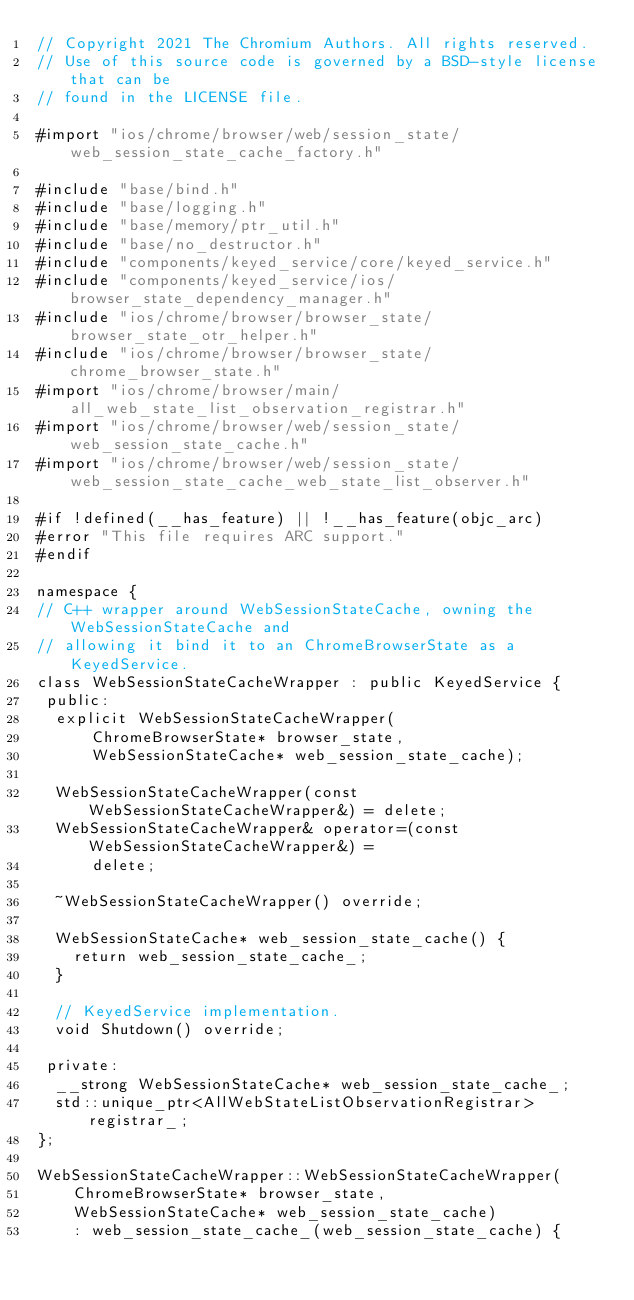<code> <loc_0><loc_0><loc_500><loc_500><_ObjectiveC_>// Copyright 2021 The Chromium Authors. All rights reserved.
// Use of this source code is governed by a BSD-style license that can be
// found in the LICENSE file.

#import "ios/chrome/browser/web/session_state/web_session_state_cache_factory.h"

#include "base/bind.h"
#include "base/logging.h"
#include "base/memory/ptr_util.h"
#include "base/no_destructor.h"
#include "components/keyed_service/core/keyed_service.h"
#include "components/keyed_service/ios/browser_state_dependency_manager.h"
#include "ios/chrome/browser/browser_state/browser_state_otr_helper.h"
#include "ios/chrome/browser/browser_state/chrome_browser_state.h"
#import "ios/chrome/browser/main/all_web_state_list_observation_registrar.h"
#import "ios/chrome/browser/web/session_state/web_session_state_cache.h"
#import "ios/chrome/browser/web/session_state/web_session_state_cache_web_state_list_observer.h"

#if !defined(__has_feature) || !__has_feature(objc_arc)
#error "This file requires ARC support."
#endif

namespace {
// C++ wrapper around WebSessionStateCache, owning the WebSessionStateCache and
// allowing it bind it to an ChromeBrowserState as a KeyedService.
class WebSessionStateCacheWrapper : public KeyedService {
 public:
  explicit WebSessionStateCacheWrapper(
      ChromeBrowserState* browser_state,
      WebSessionStateCache* web_session_state_cache);

  WebSessionStateCacheWrapper(const WebSessionStateCacheWrapper&) = delete;
  WebSessionStateCacheWrapper& operator=(const WebSessionStateCacheWrapper&) =
      delete;

  ~WebSessionStateCacheWrapper() override;

  WebSessionStateCache* web_session_state_cache() {
    return web_session_state_cache_;
  }

  // KeyedService implementation.
  void Shutdown() override;

 private:
  __strong WebSessionStateCache* web_session_state_cache_;
  std::unique_ptr<AllWebStateListObservationRegistrar> registrar_;
};

WebSessionStateCacheWrapper::WebSessionStateCacheWrapper(
    ChromeBrowserState* browser_state,
    WebSessionStateCache* web_session_state_cache)
    : web_session_state_cache_(web_session_state_cache) {</code> 